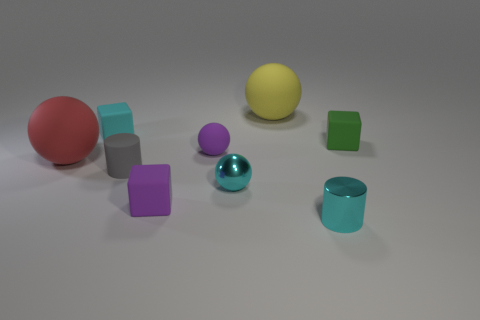The object that is to the right of the large yellow sphere and left of the green cube is what color?
Offer a terse response. Cyan. Are there any matte things on the right side of the large yellow thing?
Your response must be concise. Yes. What number of tiny metallic cylinders are to the right of the big matte ball that is right of the big red ball?
Provide a succinct answer. 1. What size is the purple ball that is the same material as the yellow thing?
Provide a succinct answer. Small. How big is the metallic cylinder?
Your answer should be compact. Small. Is the material of the cyan cylinder the same as the tiny cyan ball?
Make the answer very short. Yes. How many cubes are either yellow matte objects or rubber things?
Make the answer very short. 3. There is a big sphere that is behind the large thing that is in front of the green matte thing; what is its color?
Offer a very short reply. Yellow. How many small objects are in front of the small gray cylinder in front of the big sphere to the right of the red thing?
Your answer should be compact. 3. There is a large matte thing left of the small cyan rubber block; is its shape the same as the purple object that is in front of the red matte ball?
Offer a very short reply. No. 